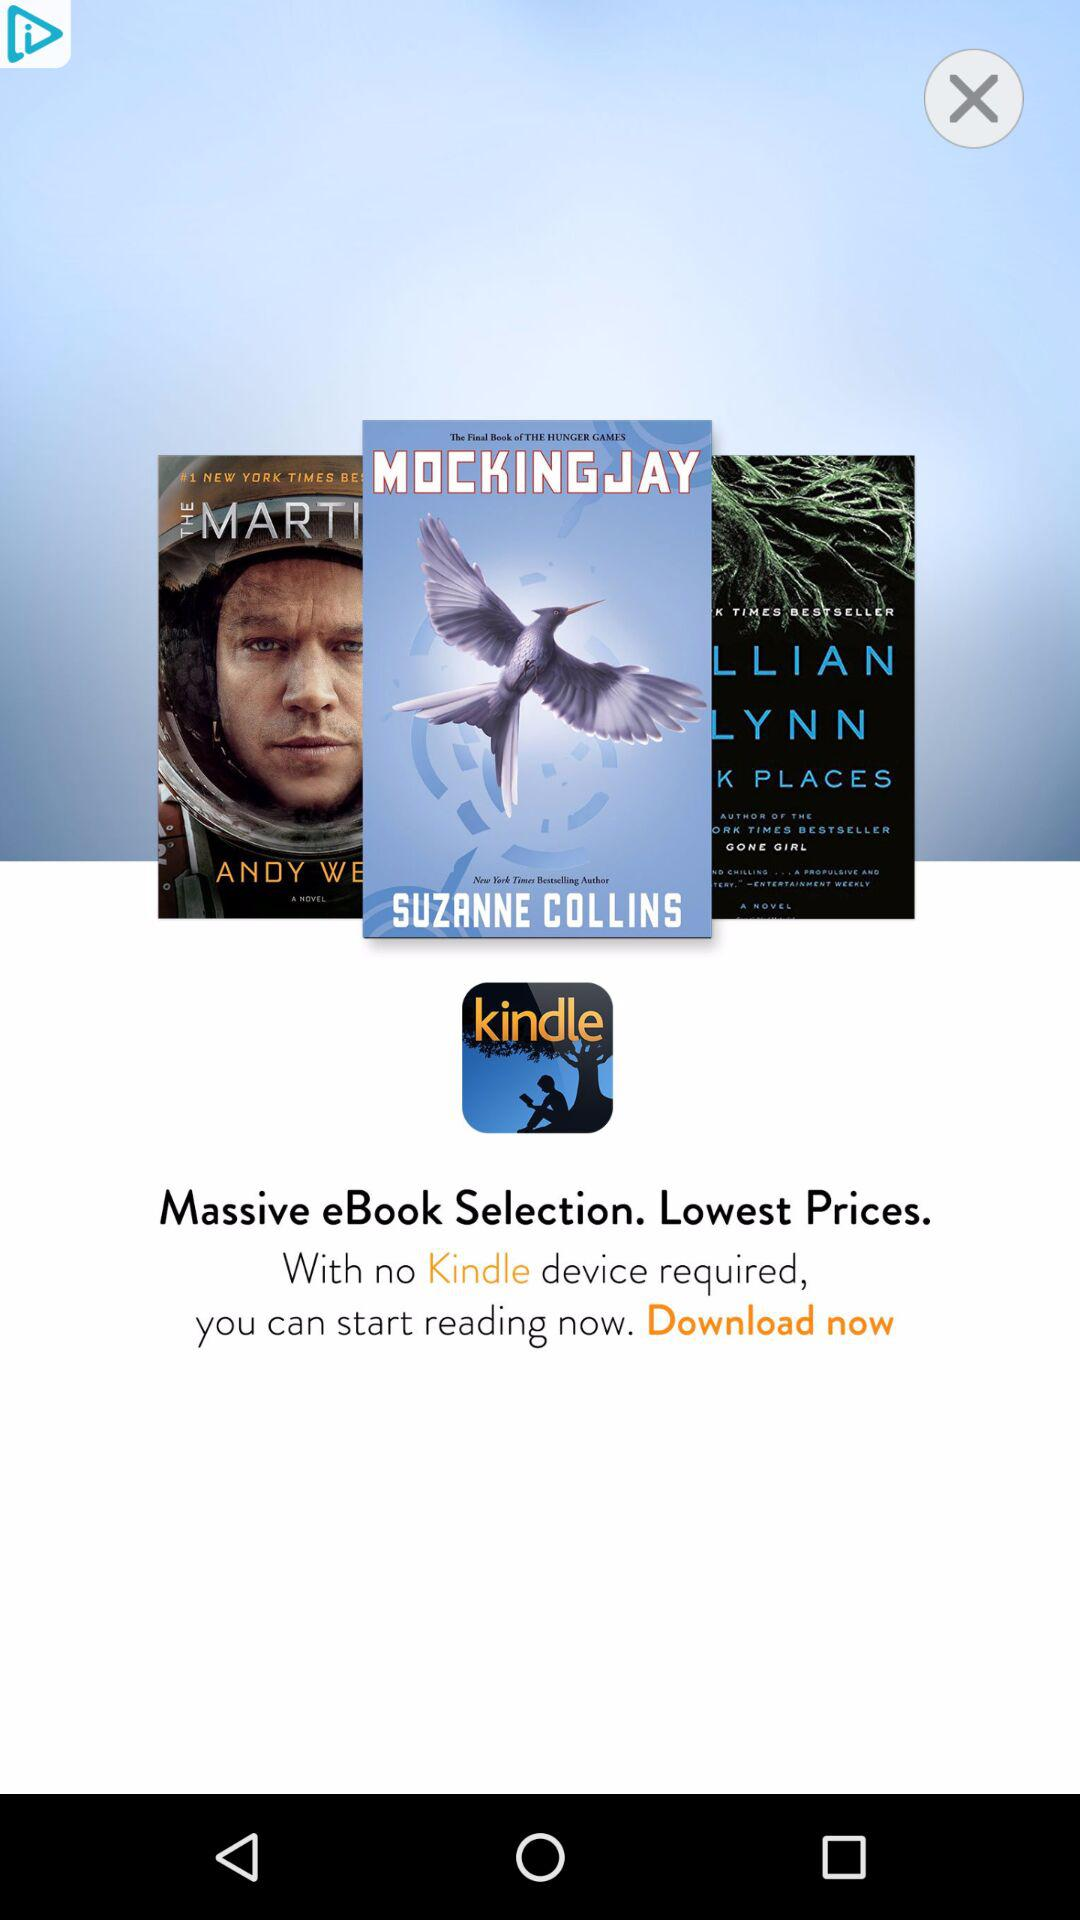How many books are displayed on the screen?
Answer the question using a single word or phrase. 3 